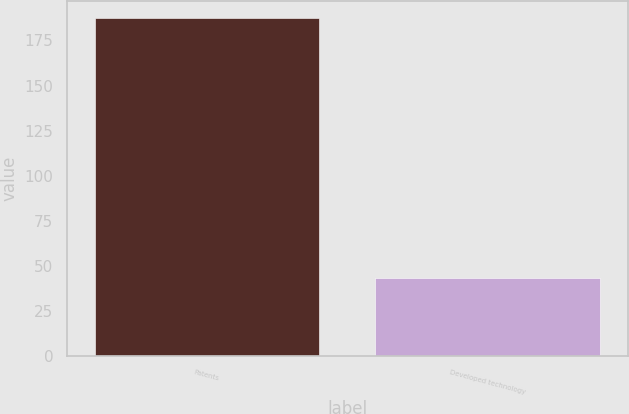<chart> <loc_0><loc_0><loc_500><loc_500><bar_chart><fcel>Patents<fcel>Developed technology<nl><fcel>187.6<fcel>43<nl></chart> 